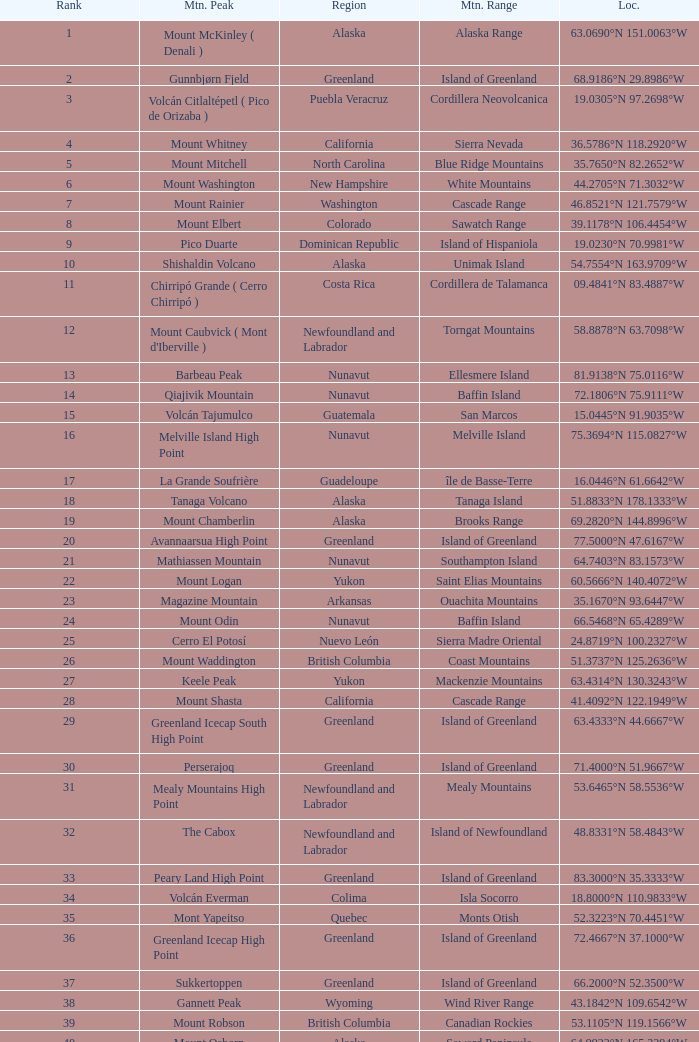Can you identify the mountain peak with a rank of 62? Cerro Nube ( Quie Yelaag ). 